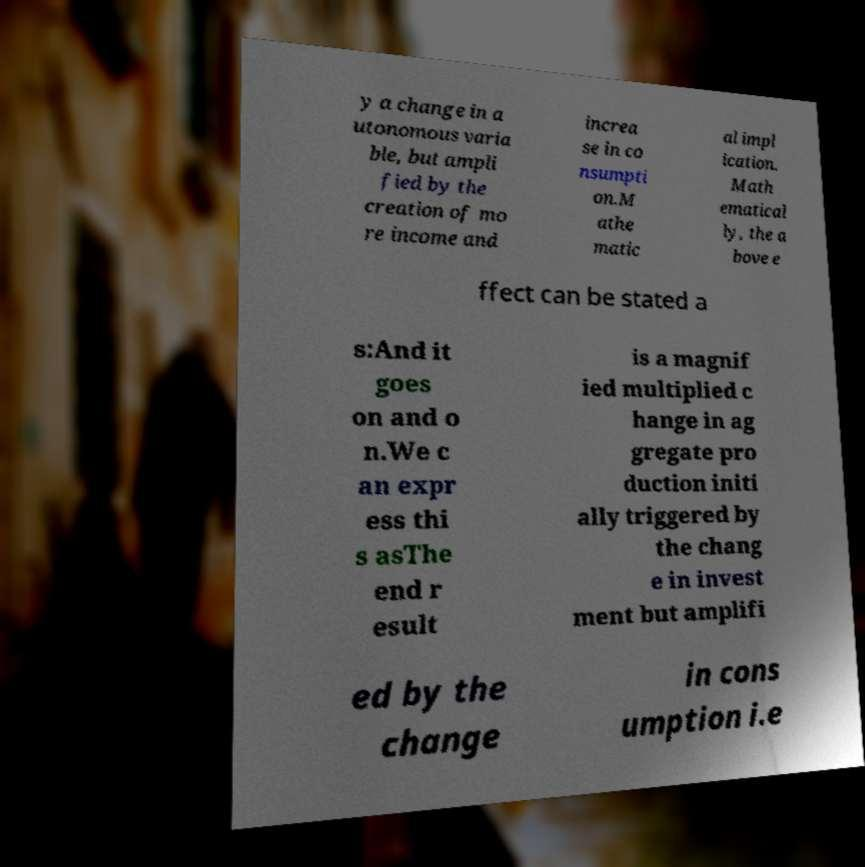Please identify and transcribe the text found in this image. y a change in a utonomous varia ble, but ampli fied by the creation of mo re income and increa se in co nsumpti on.M athe matic al impl ication. Math ematical ly, the a bove e ffect can be stated a s:And it goes on and o n.We c an expr ess thi s asThe end r esult is a magnif ied multiplied c hange in ag gregate pro duction initi ally triggered by the chang e in invest ment but amplifi ed by the change in cons umption i.e 